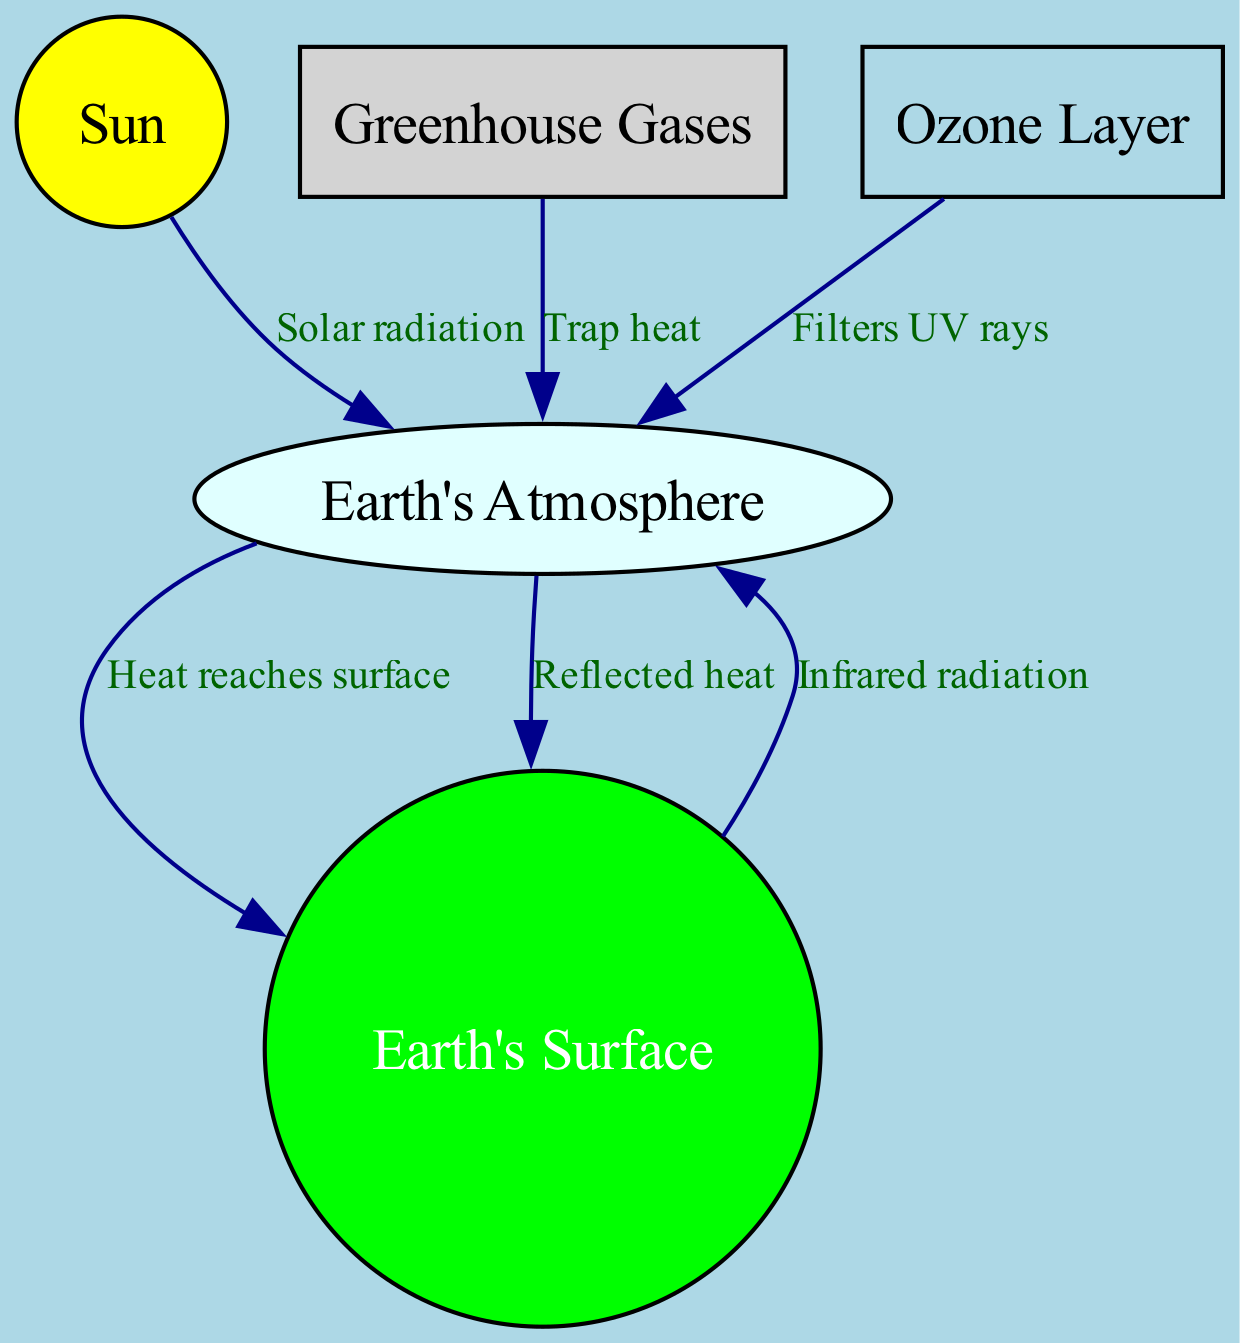What are the main components of the greenhouse effect diagram? The diagram shows five main components: Sun, Earth's Atmosphere, Earth's Surface, Greenhouse Gases, and Ozone Layer. These components represent the elements involved in the greenhouse effect.
Answer: Sun, Earth's Atmosphere, Earth's Surface, Greenhouse Gases, Ozone Layer How many nodes are in the diagram? The diagram has a total of five nodes: Sun, Earth's Atmosphere, Earth's Surface, Greenhouse Gases, and Ozone Layer. Counting these nodes gives us the answer.
Answer: 5 What is the relationship between the Sun and Earth's Atmosphere? The Sun emits solar radiation, which reaches Earth's Atmosphere. This relationship is indicated by a directed edge labeled "Solar radiation" connecting the Sun to the Atmosphere.
Answer: Solar radiation Which element is responsible for trapping heat in the atmosphere? Greenhouse Gases are indicated in the diagram as the component responsible for trapping heat, as signified by the labeled edge that points from Greenhouse Gases to the Atmosphere with the label "Trap heat".
Answer: Greenhouse Gases What does the Ozone Layer do in relation to the Earth's atmosphere? The Ozone Layer filters UV rays from the Sun, as indicated by the directed edge from the Ozone Layer to the Atmosphere, labeled "Filters UV rays".
Answer: Filters UV rays How does heat reach the Earth's surface according to the diagram? Heat reaches Earth’s surface from the Atmosphere, as shown by the directed edge labeled "Heat reaches surface" connecting the Atmosphere to Earth's Surface. This pathway indicates how energy is transferred down from the atmospheric layer.
Answer: Heat reaches surface What happens to infrared radiation emitted from the Earth's Surface? The diagram indicates that infrared radiation goes from the Earth's Surface back to the Atmosphere, highlighting the energy balance in the greenhouse effect. This relationship is shown through the labeled edge "Infrared radiation" pointing from the Earth to the Atmosphere.
Answer: Infrared radiation How many relationships (edges) are shown in the diagram? The diagram contains a total of six edges connecting the components, each representing a different interaction or flow of energy within the greenhouse effect system. Counting these gives the total number of relationships.
Answer: 6 What is reflected back to the Earth's Atmosphere? The diagram shows that heat is reflected back to the Atmosphere from the Earth’s Surface, as indicated by the directed edge labeled "Reflected heat" pointing back towards the Atmosphere.
Answer: Reflected heat 